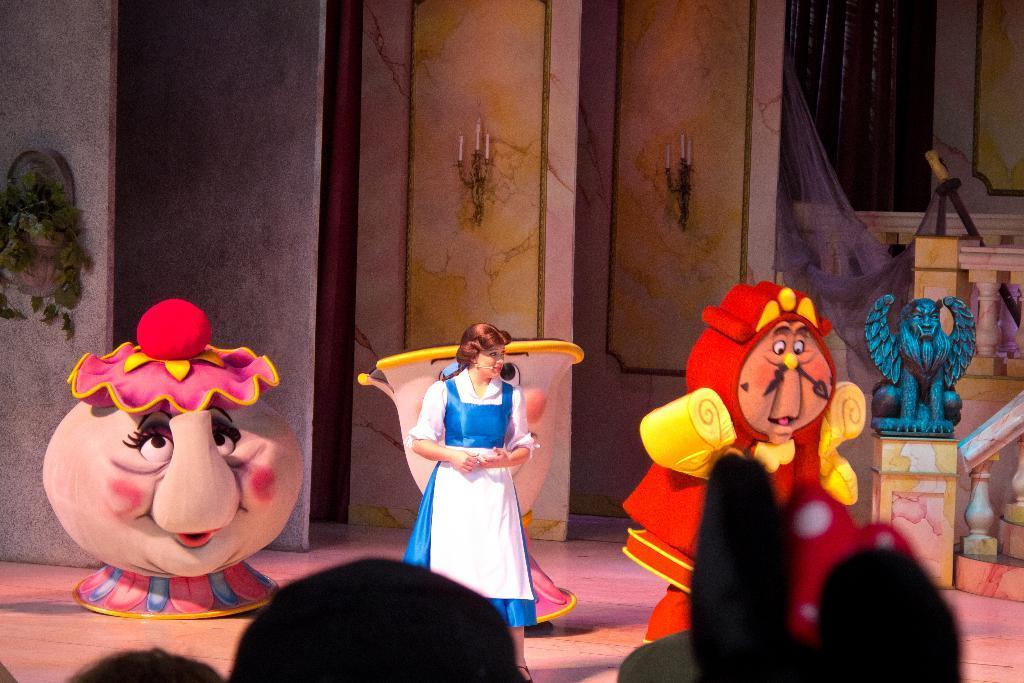In one or two sentences, can you explain what this image depicts? In this picture there is a lady who is standing in the center of the image and there are cartoon characters in the center of the image. 